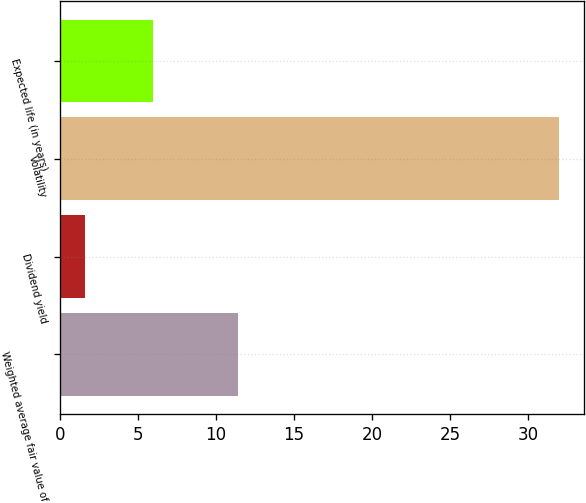Convert chart. <chart><loc_0><loc_0><loc_500><loc_500><bar_chart><fcel>Weighted average fair value of<fcel>Dividend yield<fcel>Volatility<fcel>Expected life (in years)<nl><fcel>11.4<fcel>1.59<fcel>32<fcel>5.98<nl></chart> 